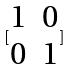<formula> <loc_0><loc_0><loc_500><loc_500>[ \begin{matrix} 1 & 0 \\ 0 & 1 \end{matrix} ]</formula> 